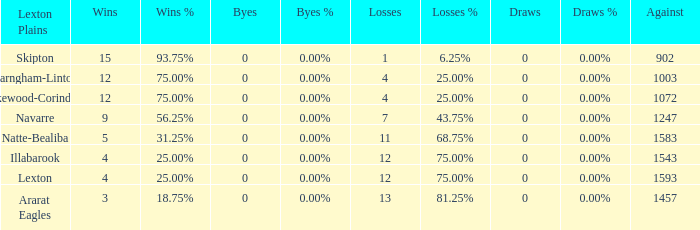What is the most wins with 0 byes? None. 